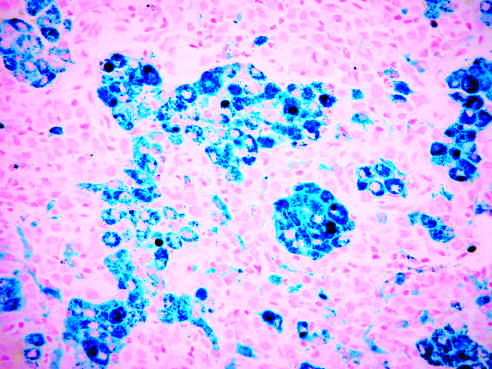has the tissue been stained with prussian blue, an iron stain that highlights the abundant intracellular hemo-siderin?
Answer the question using a single word or phrase. Yes 